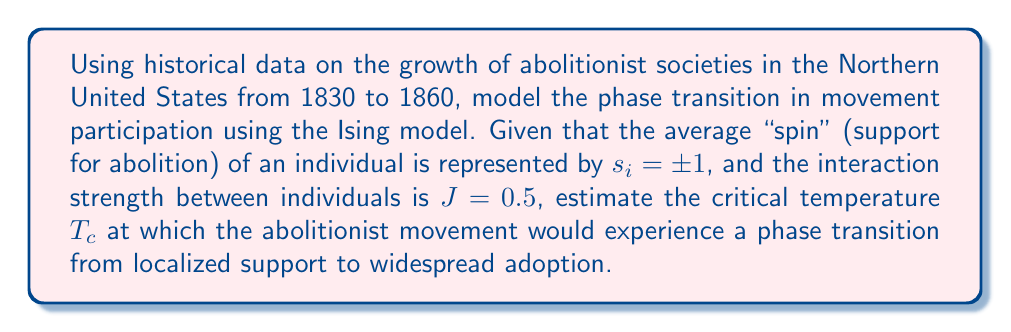Could you help me with this problem? To estimate the phase transition in the abolitionist movement growth using the Ising model, we'll follow these steps:

1. The Ising model is described by the Hamiltonian:
   $$H = -J \sum_{\langle i,j \rangle} s_i s_j$$
   where $J$ is the interaction strength and $s_i = \pm 1$ represents individual support.

2. In a mean-field approximation, the critical temperature $T_c$ for a phase transition in the 2D Ising model is given by:
   $$T_c = \frac{2J}{k_B \ln(1+\sqrt{2})}$$
   where $k_B$ is the Boltzmann constant.

3. We are given $J = 0.5$. For simplicity, let's assume $k_B = 1$ (choosing appropriate units).

4. Substituting these values:
   $$T_c = \frac{2(0.5)}{1 \cdot \ln(1+\sqrt{2})}$$

5. Simplify:
   $$T_c = \frac{1}{\ln(1+\sqrt{2})} \approx 1.1346$$

6. This critical temperature represents the point at which the abolitionist movement would transition from localized support to widespread adoption, analogous to a phase transition in statistical mechanics.
Answer: $T_c \approx 1.1346$ 